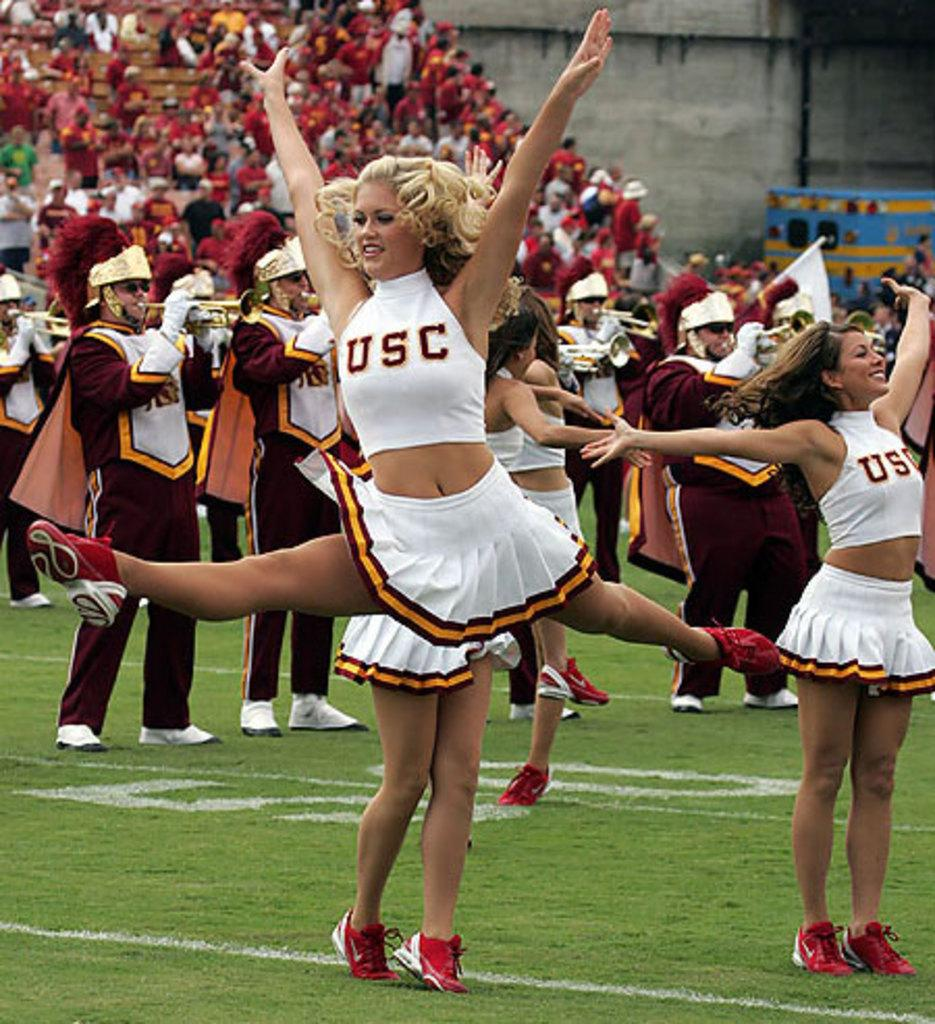<image>
Relay a brief, clear account of the picture shown. a girl jumping with the letter USC on her chest. 